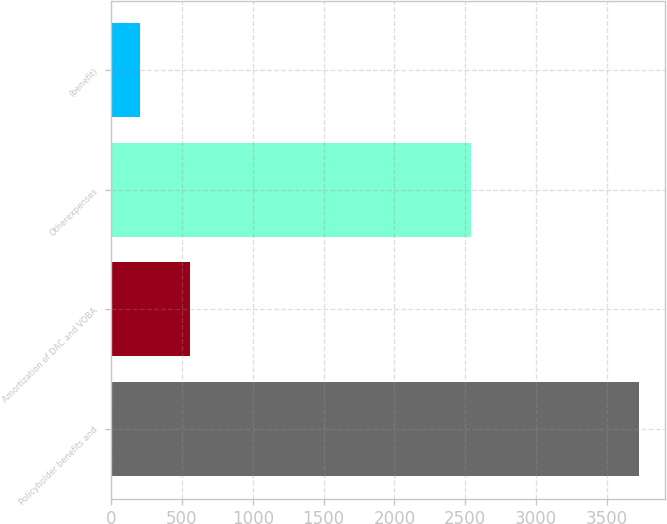<chart> <loc_0><loc_0><loc_500><loc_500><bar_chart><fcel>Policyholder benefits and<fcel>Amortization of DAC and VOBA<fcel>Otherexpenses<fcel>(benefit)<nl><fcel>3723<fcel>557.7<fcel>2538<fcel>206<nl></chart> 